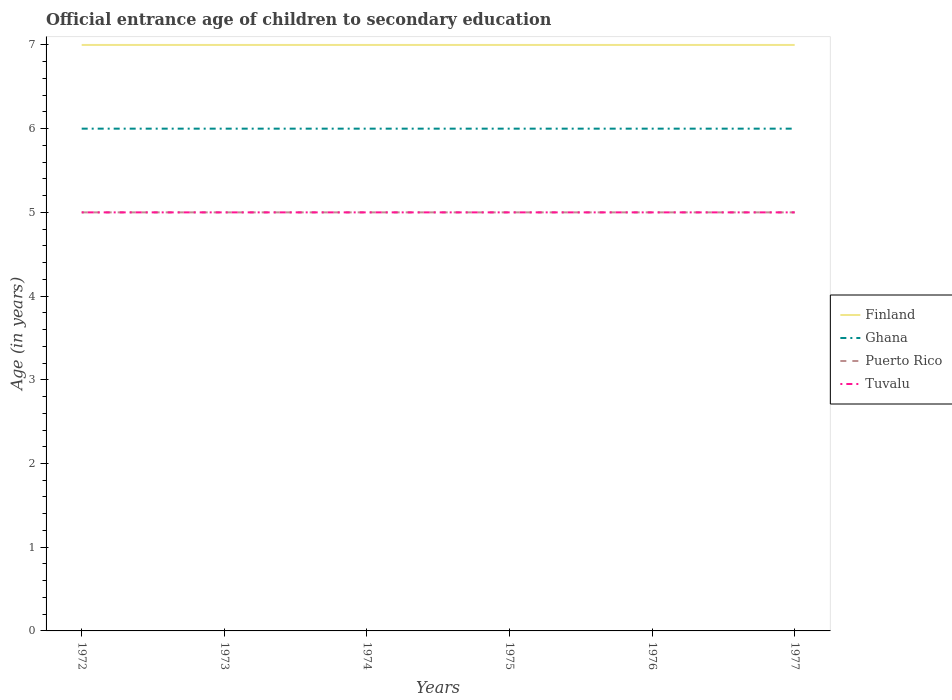Does the line corresponding to Puerto Rico intersect with the line corresponding to Tuvalu?
Provide a succinct answer. Yes. Across all years, what is the maximum secondary school starting age of children in Tuvalu?
Make the answer very short. 5. In which year was the secondary school starting age of children in Tuvalu maximum?
Ensure brevity in your answer.  1972. What is the difference between the highest and the lowest secondary school starting age of children in Tuvalu?
Offer a very short reply. 0. Is the secondary school starting age of children in Ghana strictly greater than the secondary school starting age of children in Puerto Rico over the years?
Offer a very short reply. No. What is the difference between two consecutive major ticks on the Y-axis?
Ensure brevity in your answer.  1. Are the values on the major ticks of Y-axis written in scientific E-notation?
Give a very brief answer. No. Does the graph contain any zero values?
Your answer should be very brief. No. Does the graph contain grids?
Offer a terse response. No. Where does the legend appear in the graph?
Provide a succinct answer. Center right. How many legend labels are there?
Make the answer very short. 4. What is the title of the graph?
Your response must be concise. Official entrance age of children to secondary education. What is the label or title of the X-axis?
Provide a succinct answer. Years. What is the label or title of the Y-axis?
Provide a short and direct response. Age (in years). What is the Age (in years) of Finland in 1972?
Provide a short and direct response. 7. What is the Age (in years) in Ghana in 1972?
Your answer should be compact. 6. What is the Age (in years) in Puerto Rico in 1973?
Your answer should be compact. 5. What is the Age (in years) of Finland in 1974?
Make the answer very short. 7. What is the Age (in years) of Puerto Rico in 1974?
Ensure brevity in your answer.  5. What is the Age (in years) in Tuvalu in 1974?
Give a very brief answer. 5. What is the Age (in years) of Finland in 1975?
Your answer should be very brief. 7. What is the Age (in years) of Ghana in 1975?
Keep it short and to the point. 6. What is the Age (in years) of Finland in 1976?
Give a very brief answer. 7. What is the Age (in years) in Ghana in 1976?
Make the answer very short. 6. What is the Age (in years) in Tuvalu in 1976?
Your answer should be very brief. 5. What is the Age (in years) of Finland in 1977?
Ensure brevity in your answer.  7. What is the Age (in years) in Ghana in 1977?
Your response must be concise. 6. What is the Age (in years) in Tuvalu in 1977?
Ensure brevity in your answer.  5. Across all years, what is the maximum Age (in years) of Finland?
Ensure brevity in your answer.  7. Across all years, what is the maximum Age (in years) in Ghana?
Your answer should be very brief. 6. Across all years, what is the minimum Age (in years) in Ghana?
Keep it short and to the point. 6. What is the total Age (in years) in Finland in the graph?
Make the answer very short. 42. What is the total Age (in years) in Tuvalu in the graph?
Give a very brief answer. 30. What is the difference between the Age (in years) in Puerto Rico in 1972 and that in 1973?
Give a very brief answer. 0. What is the difference between the Age (in years) in Tuvalu in 1972 and that in 1973?
Give a very brief answer. 0. What is the difference between the Age (in years) in Finland in 1972 and that in 1974?
Keep it short and to the point. 0. What is the difference between the Age (in years) of Ghana in 1972 and that in 1974?
Provide a short and direct response. 0. What is the difference between the Age (in years) of Ghana in 1972 and that in 1975?
Your answer should be compact. 0. What is the difference between the Age (in years) in Finland in 1972 and that in 1976?
Your response must be concise. 0. What is the difference between the Age (in years) in Ghana in 1972 and that in 1976?
Your response must be concise. 0. What is the difference between the Age (in years) in Puerto Rico in 1972 and that in 1976?
Ensure brevity in your answer.  0. What is the difference between the Age (in years) of Finland in 1972 and that in 1977?
Keep it short and to the point. 0. What is the difference between the Age (in years) of Tuvalu in 1972 and that in 1977?
Give a very brief answer. 0. What is the difference between the Age (in years) of Finland in 1973 and that in 1974?
Your answer should be very brief. 0. What is the difference between the Age (in years) of Ghana in 1973 and that in 1974?
Your answer should be compact. 0. What is the difference between the Age (in years) in Puerto Rico in 1973 and that in 1975?
Your answer should be very brief. 0. What is the difference between the Age (in years) of Tuvalu in 1973 and that in 1975?
Your response must be concise. 0. What is the difference between the Age (in years) in Finland in 1973 and that in 1976?
Offer a very short reply. 0. What is the difference between the Age (in years) in Ghana in 1973 and that in 1976?
Provide a short and direct response. 0. What is the difference between the Age (in years) in Tuvalu in 1973 and that in 1976?
Give a very brief answer. 0. What is the difference between the Age (in years) in Ghana in 1973 and that in 1977?
Offer a very short reply. 0. What is the difference between the Age (in years) in Finland in 1974 and that in 1976?
Your answer should be very brief. 0. What is the difference between the Age (in years) in Ghana in 1974 and that in 1976?
Give a very brief answer. 0. What is the difference between the Age (in years) of Ghana in 1974 and that in 1977?
Offer a very short reply. 0. What is the difference between the Age (in years) in Puerto Rico in 1974 and that in 1977?
Your response must be concise. 0. What is the difference between the Age (in years) of Finland in 1975 and that in 1977?
Give a very brief answer. 0. What is the difference between the Age (in years) in Puerto Rico in 1975 and that in 1977?
Offer a terse response. 0. What is the difference between the Age (in years) of Tuvalu in 1975 and that in 1977?
Your answer should be very brief. 0. What is the difference between the Age (in years) in Ghana in 1976 and that in 1977?
Ensure brevity in your answer.  0. What is the difference between the Age (in years) of Tuvalu in 1976 and that in 1977?
Provide a short and direct response. 0. What is the difference between the Age (in years) in Finland in 1972 and the Age (in years) in Puerto Rico in 1973?
Keep it short and to the point. 2. What is the difference between the Age (in years) of Finland in 1972 and the Age (in years) of Tuvalu in 1973?
Your answer should be very brief. 2. What is the difference between the Age (in years) in Ghana in 1972 and the Age (in years) in Puerto Rico in 1973?
Make the answer very short. 1. What is the difference between the Age (in years) in Ghana in 1972 and the Age (in years) in Tuvalu in 1973?
Keep it short and to the point. 1. What is the difference between the Age (in years) of Puerto Rico in 1972 and the Age (in years) of Tuvalu in 1973?
Provide a succinct answer. 0. What is the difference between the Age (in years) of Finland in 1972 and the Age (in years) of Tuvalu in 1974?
Give a very brief answer. 2. What is the difference between the Age (in years) of Ghana in 1972 and the Age (in years) of Puerto Rico in 1974?
Your answer should be compact. 1. What is the difference between the Age (in years) of Puerto Rico in 1972 and the Age (in years) of Tuvalu in 1974?
Offer a terse response. 0. What is the difference between the Age (in years) of Finland in 1972 and the Age (in years) of Puerto Rico in 1975?
Offer a very short reply. 2. What is the difference between the Age (in years) of Ghana in 1972 and the Age (in years) of Puerto Rico in 1975?
Ensure brevity in your answer.  1. What is the difference between the Age (in years) in Ghana in 1972 and the Age (in years) in Tuvalu in 1975?
Keep it short and to the point. 1. What is the difference between the Age (in years) of Puerto Rico in 1972 and the Age (in years) of Tuvalu in 1975?
Offer a very short reply. 0. What is the difference between the Age (in years) in Finland in 1972 and the Age (in years) in Ghana in 1976?
Give a very brief answer. 1. What is the difference between the Age (in years) in Finland in 1972 and the Age (in years) in Tuvalu in 1976?
Keep it short and to the point. 2. What is the difference between the Age (in years) of Ghana in 1972 and the Age (in years) of Puerto Rico in 1976?
Offer a very short reply. 1. What is the difference between the Age (in years) of Ghana in 1972 and the Age (in years) of Tuvalu in 1976?
Provide a succinct answer. 1. What is the difference between the Age (in years) in Finland in 1972 and the Age (in years) in Ghana in 1977?
Offer a very short reply. 1. What is the difference between the Age (in years) in Finland in 1972 and the Age (in years) in Puerto Rico in 1977?
Give a very brief answer. 2. What is the difference between the Age (in years) of Finland in 1972 and the Age (in years) of Tuvalu in 1977?
Keep it short and to the point. 2. What is the difference between the Age (in years) of Ghana in 1972 and the Age (in years) of Puerto Rico in 1977?
Your answer should be very brief. 1. What is the difference between the Age (in years) in Puerto Rico in 1972 and the Age (in years) in Tuvalu in 1977?
Your answer should be very brief. 0. What is the difference between the Age (in years) of Ghana in 1973 and the Age (in years) of Tuvalu in 1974?
Make the answer very short. 1. What is the difference between the Age (in years) of Finland in 1973 and the Age (in years) of Puerto Rico in 1975?
Offer a very short reply. 2. What is the difference between the Age (in years) of Finland in 1973 and the Age (in years) of Tuvalu in 1975?
Make the answer very short. 2. What is the difference between the Age (in years) of Ghana in 1973 and the Age (in years) of Tuvalu in 1975?
Make the answer very short. 1. What is the difference between the Age (in years) of Finland in 1973 and the Age (in years) of Tuvalu in 1976?
Offer a terse response. 2. What is the difference between the Age (in years) in Ghana in 1973 and the Age (in years) in Tuvalu in 1976?
Your answer should be compact. 1. What is the difference between the Age (in years) of Puerto Rico in 1973 and the Age (in years) of Tuvalu in 1976?
Make the answer very short. 0. What is the difference between the Age (in years) in Finland in 1973 and the Age (in years) in Ghana in 1977?
Give a very brief answer. 1. What is the difference between the Age (in years) in Finland in 1973 and the Age (in years) in Tuvalu in 1977?
Offer a terse response. 2. What is the difference between the Age (in years) of Puerto Rico in 1973 and the Age (in years) of Tuvalu in 1977?
Your answer should be compact. 0. What is the difference between the Age (in years) in Finland in 1974 and the Age (in years) in Ghana in 1975?
Your response must be concise. 1. What is the difference between the Age (in years) in Puerto Rico in 1974 and the Age (in years) in Tuvalu in 1975?
Make the answer very short. 0. What is the difference between the Age (in years) in Finland in 1974 and the Age (in years) in Tuvalu in 1976?
Make the answer very short. 2. What is the difference between the Age (in years) in Ghana in 1974 and the Age (in years) in Puerto Rico in 1976?
Your response must be concise. 1. What is the difference between the Age (in years) in Puerto Rico in 1974 and the Age (in years) in Tuvalu in 1976?
Your answer should be very brief. 0. What is the difference between the Age (in years) in Finland in 1974 and the Age (in years) in Ghana in 1977?
Offer a terse response. 1. What is the difference between the Age (in years) of Finland in 1974 and the Age (in years) of Puerto Rico in 1977?
Make the answer very short. 2. What is the difference between the Age (in years) in Finland in 1974 and the Age (in years) in Tuvalu in 1977?
Provide a short and direct response. 2. What is the difference between the Age (in years) of Finland in 1975 and the Age (in years) of Puerto Rico in 1976?
Keep it short and to the point. 2. What is the difference between the Age (in years) of Finland in 1975 and the Age (in years) of Tuvalu in 1976?
Offer a terse response. 2. What is the difference between the Age (in years) of Puerto Rico in 1975 and the Age (in years) of Tuvalu in 1976?
Your answer should be very brief. 0. What is the difference between the Age (in years) of Finland in 1975 and the Age (in years) of Ghana in 1977?
Your answer should be very brief. 1. What is the difference between the Age (in years) of Finland in 1975 and the Age (in years) of Puerto Rico in 1977?
Ensure brevity in your answer.  2. What is the difference between the Age (in years) of Finland in 1975 and the Age (in years) of Tuvalu in 1977?
Ensure brevity in your answer.  2. What is the difference between the Age (in years) of Ghana in 1975 and the Age (in years) of Puerto Rico in 1977?
Your response must be concise. 1. What is the difference between the Age (in years) of Puerto Rico in 1975 and the Age (in years) of Tuvalu in 1977?
Offer a very short reply. 0. What is the difference between the Age (in years) in Finland in 1976 and the Age (in years) in Ghana in 1977?
Keep it short and to the point. 1. What is the difference between the Age (in years) in Finland in 1976 and the Age (in years) in Tuvalu in 1977?
Provide a succinct answer. 2. What is the difference between the Age (in years) in Ghana in 1976 and the Age (in years) in Puerto Rico in 1977?
Provide a short and direct response. 1. What is the difference between the Age (in years) of Puerto Rico in 1976 and the Age (in years) of Tuvalu in 1977?
Make the answer very short. 0. What is the average Age (in years) in Finland per year?
Your answer should be very brief. 7. What is the average Age (in years) of Ghana per year?
Provide a short and direct response. 6. What is the average Age (in years) in Puerto Rico per year?
Give a very brief answer. 5. In the year 1972, what is the difference between the Age (in years) of Finland and Age (in years) of Ghana?
Offer a terse response. 1. In the year 1972, what is the difference between the Age (in years) of Finland and Age (in years) of Tuvalu?
Keep it short and to the point. 2. In the year 1972, what is the difference between the Age (in years) in Ghana and Age (in years) in Puerto Rico?
Offer a very short reply. 1. In the year 1973, what is the difference between the Age (in years) in Finland and Age (in years) in Ghana?
Your response must be concise. 1. In the year 1973, what is the difference between the Age (in years) in Ghana and Age (in years) in Puerto Rico?
Give a very brief answer. 1. In the year 1973, what is the difference between the Age (in years) in Puerto Rico and Age (in years) in Tuvalu?
Give a very brief answer. 0. In the year 1974, what is the difference between the Age (in years) in Finland and Age (in years) in Puerto Rico?
Give a very brief answer. 2. In the year 1975, what is the difference between the Age (in years) in Finland and Age (in years) in Ghana?
Your response must be concise. 1. In the year 1975, what is the difference between the Age (in years) of Finland and Age (in years) of Puerto Rico?
Your answer should be compact. 2. In the year 1975, what is the difference between the Age (in years) of Finland and Age (in years) of Tuvalu?
Keep it short and to the point. 2. In the year 1975, what is the difference between the Age (in years) in Ghana and Age (in years) in Puerto Rico?
Ensure brevity in your answer.  1. In the year 1975, what is the difference between the Age (in years) of Puerto Rico and Age (in years) of Tuvalu?
Keep it short and to the point. 0. In the year 1976, what is the difference between the Age (in years) of Ghana and Age (in years) of Puerto Rico?
Keep it short and to the point. 1. In the year 1977, what is the difference between the Age (in years) in Finland and Age (in years) in Ghana?
Give a very brief answer. 1. In the year 1977, what is the difference between the Age (in years) of Finland and Age (in years) of Puerto Rico?
Provide a succinct answer. 2. In the year 1977, what is the difference between the Age (in years) of Ghana and Age (in years) of Tuvalu?
Your answer should be very brief. 1. What is the ratio of the Age (in years) in Finland in 1972 to that in 1973?
Ensure brevity in your answer.  1. What is the ratio of the Age (in years) in Tuvalu in 1972 to that in 1973?
Provide a short and direct response. 1. What is the ratio of the Age (in years) of Finland in 1972 to that in 1974?
Make the answer very short. 1. What is the ratio of the Age (in years) in Ghana in 1972 to that in 1974?
Give a very brief answer. 1. What is the ratio of the Age (in years) in Finland in 1972 to that in 1975?
Ensure brevity in your answer.  1. What is the ratio of the Age (in years) of Tuvalu in 1972 to that in 1976?
Your answer should be very brief. 1. What is the ratio of the Age (in years) of Finland in 1972 to that in 1977?
Offer a terse response. 1. What is the ratio of the Age (in years) in Ghana in 1973 to that in 1974?
Offer a very short reply. 1. What is the ratio of the Age (in years) in Tuvalu in 1973 to that in 1974?
Your answer should be compact. 1. What is the ratio of the Age (in years) of Finland in 1973 to that in 1975?
Your answer should be compact. 1. What is the ratio of the Age (in years) of Ghana in 1973 to that in 1975?
Provide a short and direct response. 1. What is the ratio of the Age (in years) of Puerto Rico in 1973 to that in 1975?
Your answer should be compact. 1. What is the ratio of the Age (in years) of Tuvalu in 1973 to that in 1975?
Make the answer very short. 1. What is the ratio of the Age (in years) in Finland in 1973 to that in 1976?
Your answer should be compact. 1. What is the ratio of the Age (in years) in Tuvalu in 1973 to that in 1976?
Ensure brevity in your answer.  1. What is the ratio of the Age (in years) in Finland in 1973 to that in 1977?
Make the answer very short. 1. What is the ratio of the Age (in years) in Ghana in 1973 to that in 1977?
Keep it short and to the point. 1. What is the ratio of the Age (in years) of Tuvalu in 1973 to that in 1977?
Give a very brief answer. 1. What is the ratio of the Age (in years) in Finland in 1974 to that in 1975?
Give a very brief answer. 1. What is the ratio of the Age (in years) of Ghana in 1974 to that in 1975?
Offer a very short reply. 1. What is the ratio of the Age (in years) of Puerto Rico in 1974 to that in 1975?
Keep it short and to the point. 1. What is the ratio of the Age (in years) in Tuvalu in 1974 to that in 1975?
Offer a terse response. 1. What is the ratio of the Age (in years) of Ghana in 1974 to that in 1976?
Your answer should be compact. 1. What is the ratio of the Age (in years) of Finland in 1974 to that in 1977?
Ensure brevity in your answer.  1. What is the ratio of the Age (in years) of Finland in 1975 to that in 1976?
Offer a very short reply. 1. What is the ratio of the Age (in years) of Ghana in 1975 to that in 1976?
Make the answer very short. 1. What is the ratio of the Age (in years) in Puerto Rico in 1975 to that in 1976?
Your response must be concise. 1. What is the ratio of the Age (in years) in Finland in 1975 to that in 1977?
Give a very brief answer. 1. What is the ratio of the Age (in years) of Ghana in 1975 to that in 1977?
Ensure brevity in your answer.  1. What is the ratio of the Age (in years) in Puerto Rico in 1975 to that in 1977?
Offer a terse response. 1. What is the ratio of the Age (in years) of Ghana in 1976 to that in 1977?
Offer a terse response. 1. What is the ratio of the Age (in years) of Puerto Rico in 1976 to that in 1977?
Give a very brief answer. 1. What is the ratio of the Age (in years) in Tuvalu in 1976 to that in 1977?
Your answer should be compact. 1. What is the difference between the highest and the second highest Age (in years) in Puerto Rico?
Give a very brief answer. 0. What is the difference between the highest and the lowest Age (in years) in Puerto Rico?
Make the answer very short. 0. What is the difference between the highest and the lowest Age (in years) of Tuvalu?
Keep it short and to the point. 0. 